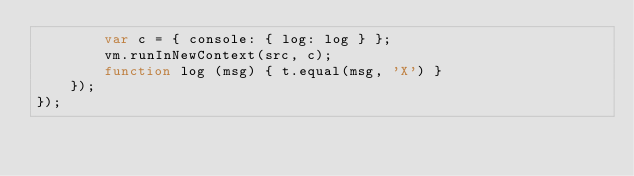<code> <loc_0><loc_0><loc_500><loc_500><_JavaScript_>        var c = { console: { log: log } };
        vm.runInNewContext(src, c);
        function log (msg) { t.equal(msg, 'X') }
    });
});
</code> 